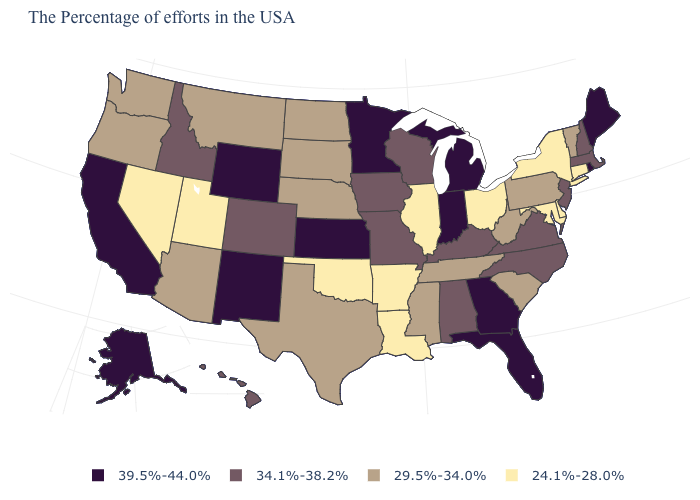Does the first symbol in the legend represent the smallest category?
Quick response, please. No. Does Delaware have the lowest value in the USA?
Give a very brief answer. Yes. What is the value of Ohio?
Short answer required. 24.1%-28.0%. What is the value of Alabama?
Keep it brief. 34.1%-38.2%. What is the value of Kentucky?
Be succinct. 34.1%-38.2%. Does Massachusetts have the lowest value in the USA?
Keep it brief. No. What is the value of Wyoming?
Be succinct. 39.5%-44.0%. What is the lowest value in states that border Virginia?
Keep it brief. 24.1%-28.0%. Does New Mexico have the highest value in the West?
Concise answer only. Yes. What is the value of Kentucky?
Keep it brief. 34.1%-38.2%. What is the value of South Dakota?
Be succinct. 29.5%-34.0%. Does the map have missing data?
Write a very short answer. No. Is the legend a continuous bar?
Keep it brief. No. Does the first symbol in the legend represent the smallest category?
Give a very brief answer. No. Does Oklahoma have a lower value than Hawaii?
Concise answer only. Yes. 